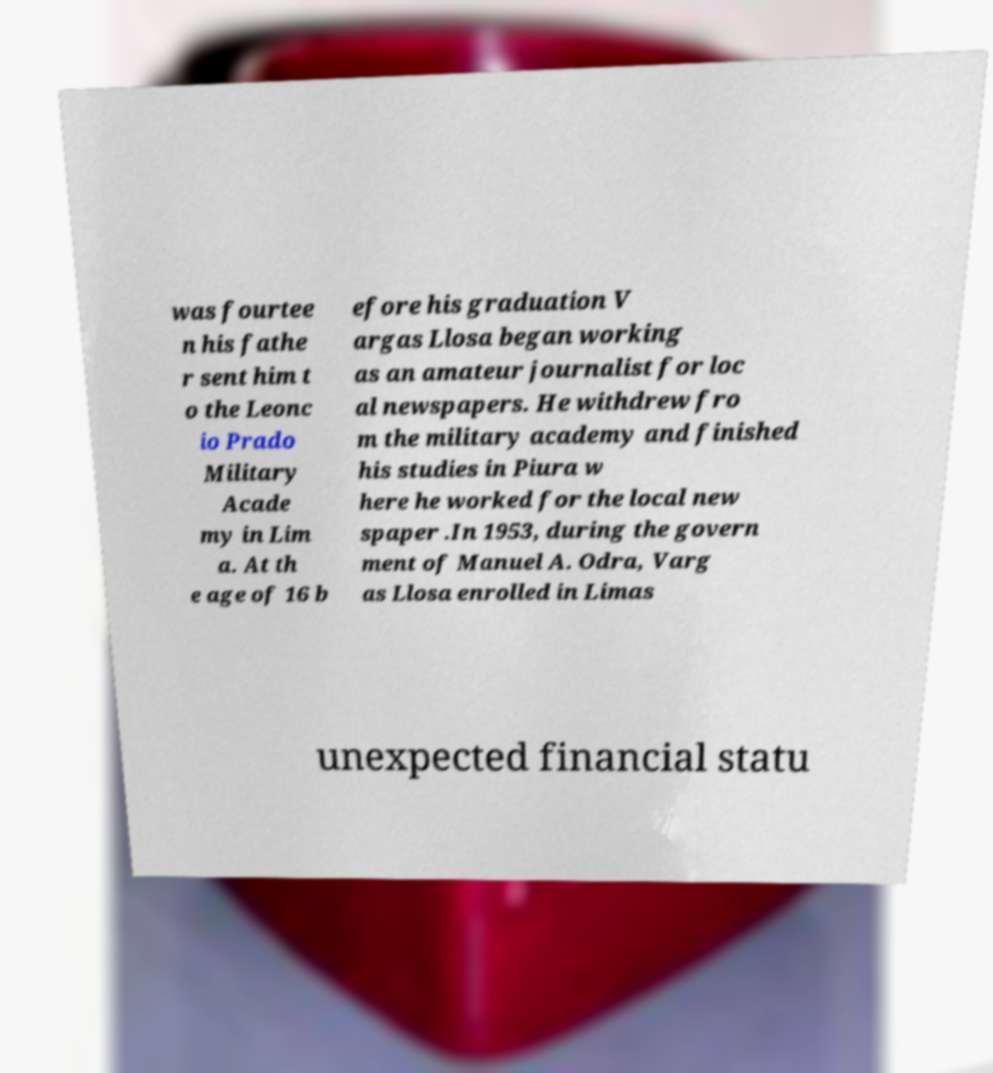Can you accurately transcribe the text from the provided image for me? was fourtee n his fathe r sent him t o the Leonc io Prado Military Acade my in Lim a. At th e age of 16 b efore his graduation V argas Llosa began working as an amateur journalist for loc al newspapers. He withdrew fro m the military academy and finished his studies in Piura w here he worked for the local new spaper .In 1953, during the govern ment of Manuel A. Odra, Varg as Llosa enrolled in Limas unexpected financial statu 